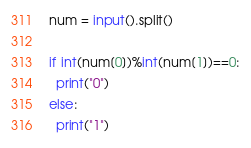<code> <loc_0><loc_0><loc_500><loc_500><_Python_>num = input().split()

if int(num[0])%int(num[1])==0:
  print("0")
else:
  print("1")</code> 